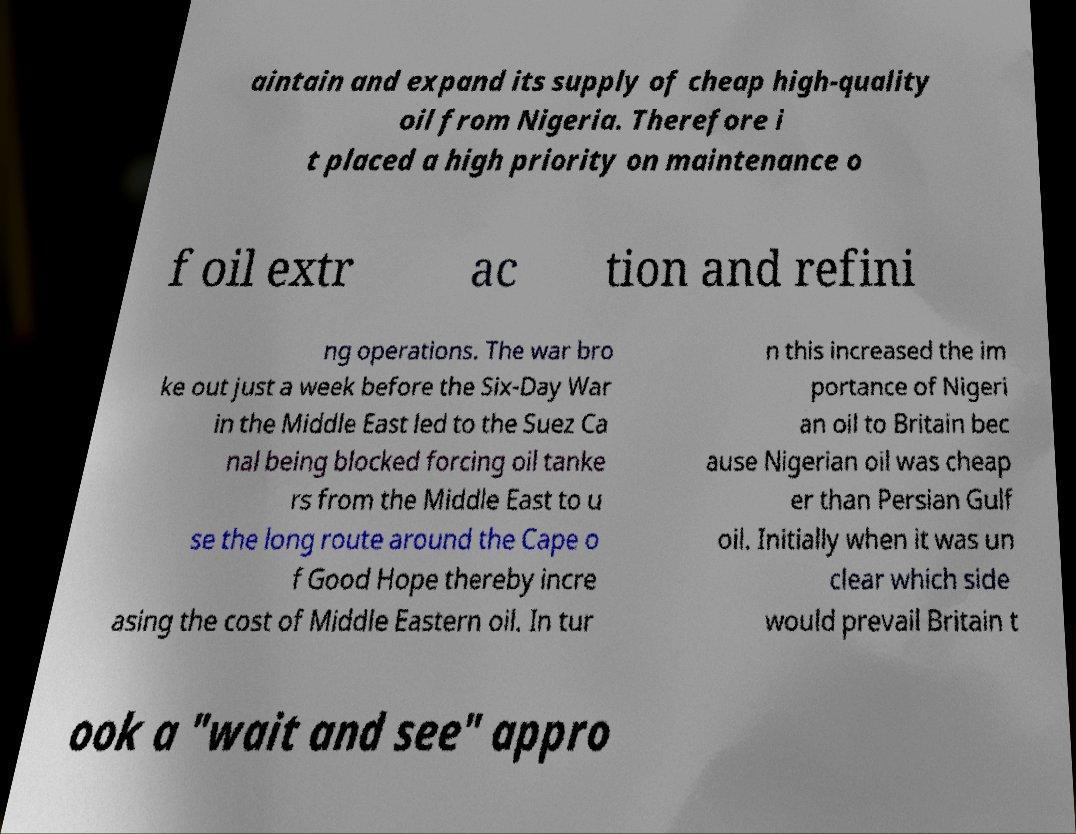Please identify and transcribe the text found in this image. aintain and expand its supply of cheap high-quality oil from Nigeria. Therefore i t placed a high priority on maintenance o f oil extr ac tion and refini ng operations. The war bro ke out just a week before the Six-Day War in the Middle East led to the Suez Ca nal being blocked forcing oil tanke rs from the Middle East to u se the long route around the Cape o f Good Hope thereby incre asing the cost of Middle Eastern oil. In tur n this increased the im portance of Nigeri an oil to Britain bec ause Nigerian oil was cheap er than Persian Gulf oil. Initially when it was un clear which side would prevail Britain t ook a "wait and see" appro 